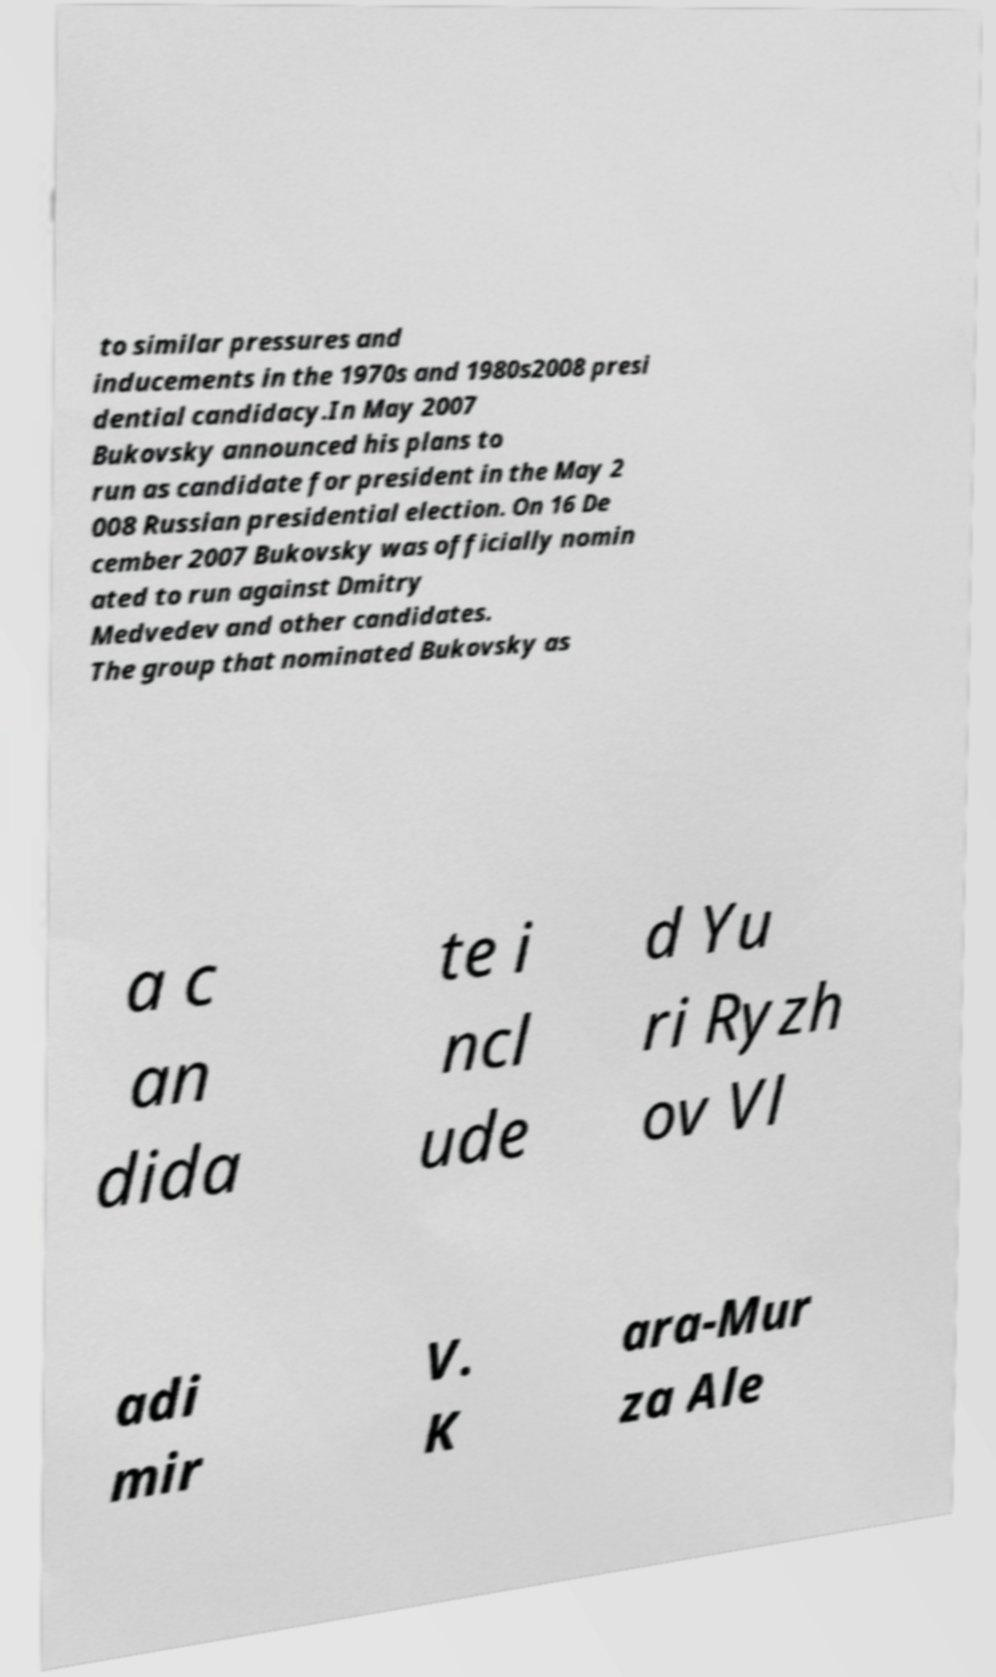I need the written content from this picture converted into text. Can you do that? to similar pressures and inducements in the 1970s and 1980s2008 presi dential candidacy.In May 2007 Bukovsky announced his plans to run as candidate for president in the May 2 008 Russian presidential election. On 16 De cember 2007 Bukovsky was officially nomin ated to run against Dmitry Medvedev and other candidates. The group that nominated Bukovsky as a c an dida te i ncl ude d Yu ri Ryzh ov Vl adi mir V. K ara-Mur za Ale 